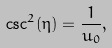<formula> <loc_0><loc_0><loc_500><loc_500>\csc ^ { 2 } ( \eta ) = \frac { 1 } { u _ { 0 } } ,</formula> 